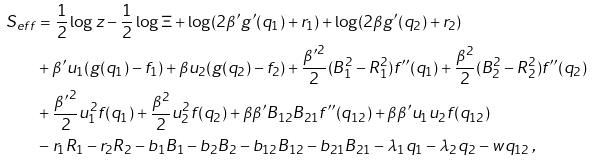<formula> <loc_0><loc_0><loc_500><loc_500>S _ { e f f } & = \frac { 1 } { 2 } \log z - \frac { 1 } { 2 } \log \Xi + \log ( 2 \beta ^ { \prime } g ^ { \prime } ( q _ { 1 } ) + r _ { 1 } ) + \log ( 2 \beta g ^ { \prime } ( q _ { 2 } ) + r _ { 2 } ) \\ & + \beta ^ { \prime } u _ { 1 } ( g ( q _ { 1 } ) - f _ { 1 } ) + \beta u _ { 2 } ( g ( q _ { 2 } ) - f _ { 2 } ) + \frac { { \beta ^ { \prime } } ^ { 2 } } { 2 } ( B _ { 1 } ^ { 2 } - R _ { 1 } ^ { 2 } ) f ^ { \prime \prime } ( q _ { 1 } ) + \frac { \beta ^ { 2 } } { 2 } ( B _ { 2 } ^ { 2 } - R _ { 2 } ^ { 2 } ) f ^ { \prime \prime } ( q _ { 2 } ) \\ & + \frac { { \beta ^ { \prime } } ^ { 2 } } { 2 } u _ { 1 } ^ { 2 } f ( q _ { 1 } ) + \frac { \beta ^ { 2 } } { 2 } u _ { 2 } ^ { 2 } f ( q _ { 2 } ) + \beta \beta ^ { \prime } B _ { 1 2 } B _ { 2 1 } f ^ { \prime \prime } ( q _ { 1 2 } ) + \beta \beta ^ { \prime } u _ { 1 } u _ { 2 } f ( q _ { 1 2 } ) \\ & - r _ { 1 } R _ { 1 } - r _ { 2 } R _ { 2 } - b _ { 1 } B _ { 1 } - b _ { 2 } B _ { 2 } - b _ { 1 2 } B _ { 1 2 } - b _ { 2 1 } B _ { 2 1 } - \lambda _ { 1 } q _ { 1 } - \lambda _ { 2 } q _ { 2 } - w q _ { 1 2 } \, ,</formula> 